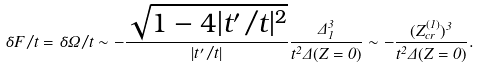<formula> <loc_0><loc_0><loc_500><loc_500>\delta F / t = \delta \Omega / t \sim - \frac { \sqrt { 1 - 4 | t ^ { \prime } / t | ^ { 2 } } } { | t ^ { \prime } / t | } \frac { \Delta _ { 1 } ^ { 3 } } { t ^ { 2 } \Delta ( Z = 0 ) } \sim - \frac { ( Z _ { c r } ^ { ( 1 ) } ) ^ { 3 } } { t ^ { 2 } \Delta ( Z = 0 ) } .</formula> 